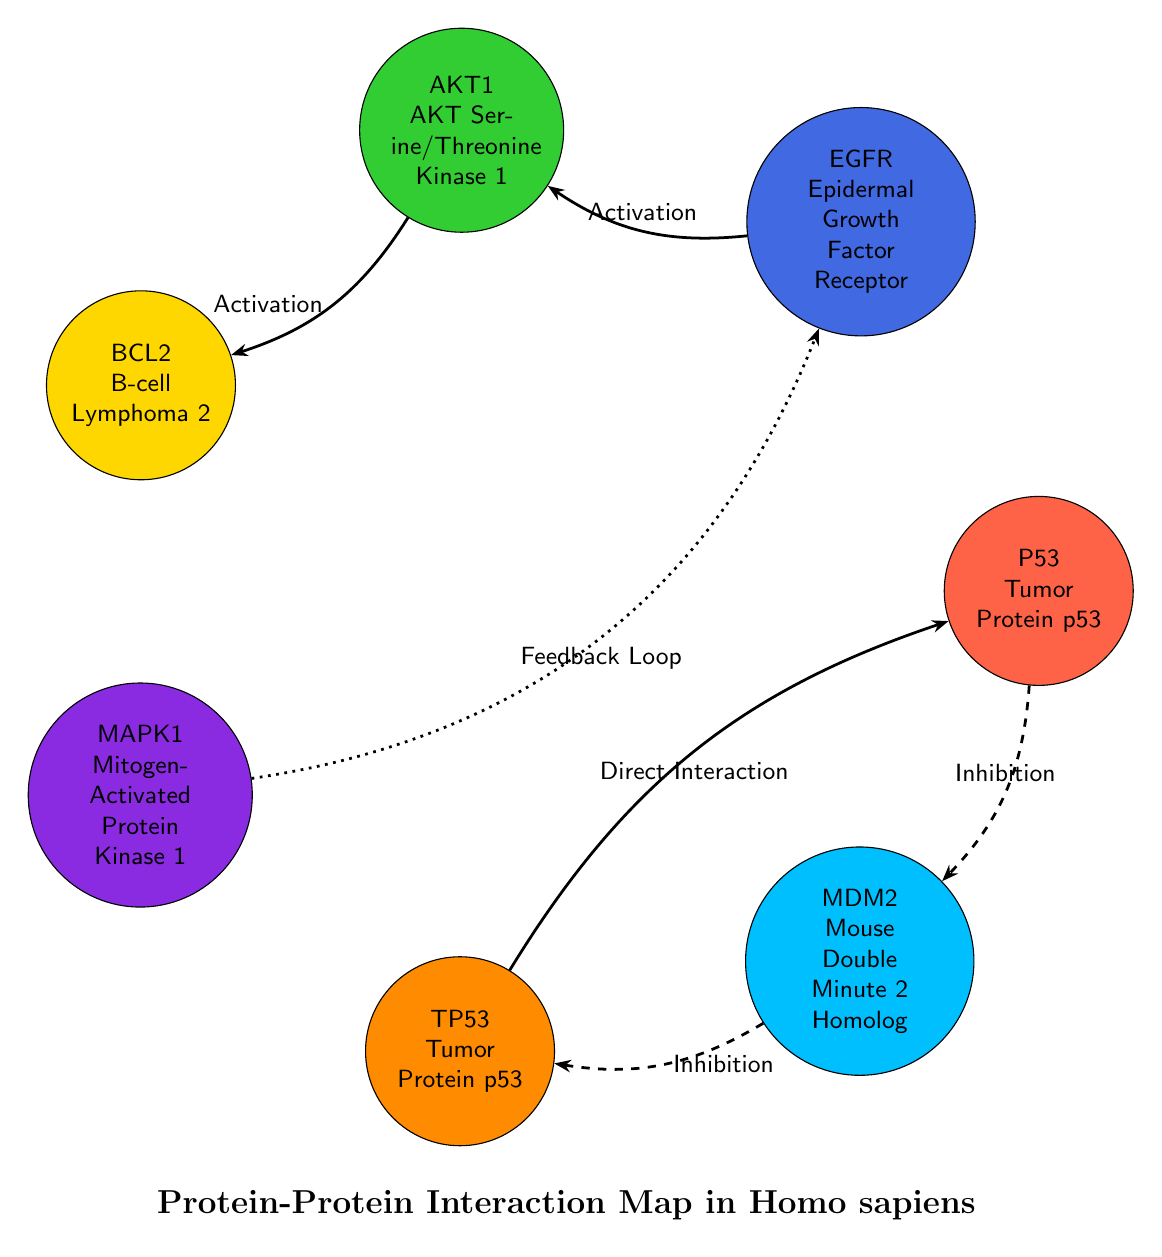What is the total number of proteins in the diagram? The diagram shows a list of proteins that are represented as nodes. By counting these nodes, we see that there are 7 distinct proteins: P53, EGFR, AKT1, BCL2, MAPK1, TP53, and MDM2.
Answer: 7 Which protein has an interaction type of "Inhibition"? Looking at the connection lines labeled with interaction types, the interactions involving 'Inhibition' are between the proteins P53 and MDM2, as well as MDM2 and TP53. Therefore, at least two proteins involve inhibition.
Answer: P53, MDM2, TP53 What type of interaction occurs between EGFR and AKT1? The line connecting EGFR to AKT1 is labeled "Activation." This indicates that the relationship is one where mutual enhancement occurs.
Answer: Activation How many direct interactions are indicated in total? The diagram specifies that there are three direct interactions. These are between P53 and MDM2, MDM2 and TP53, and also TP53 and P53. Each relationship is labeled accordingly on the diagram.
Answer: 3 Which protein interacts with MAPK1 through a feedback loop? Observing the connection from MAPK1, the line leading to EGFR is labeled "Feedback Loop." This indicates that the interaction has a latter reinforcing effect back to EGFR.
Answer: EGFR How many distinct pathways are highlighted for the protein BCL2? By examining BCL2’s pathways shown in the protein description, it is attributed to two pathways: “Apoptosis” and “Cell Survival.” This indicates multiple functional implications for this protein.
Answer: 2 Which protein interacts with P53? The diagram indicates a direct interaction from P53 to MDM2 as labeled in their connecting line. Thus, P53 has a clear point of interaction with MDM2.
Answer: MDM2 What is the relationship type between AKT1 and BCL2? The interaction line between AKT1 and BCL2 is marked as "Activation," indicating that AKT1 positively influences BCL2's function.
Answer: Activation Is there any protein that has the same name but a different protein ID? Both P53 and TP53 are present in the diagram, but they have similar functions yet different identifiers. The protein TP53 is an alias for the human P53 tumor suppressor protein.
Answer: Yes, P53 and TP53 